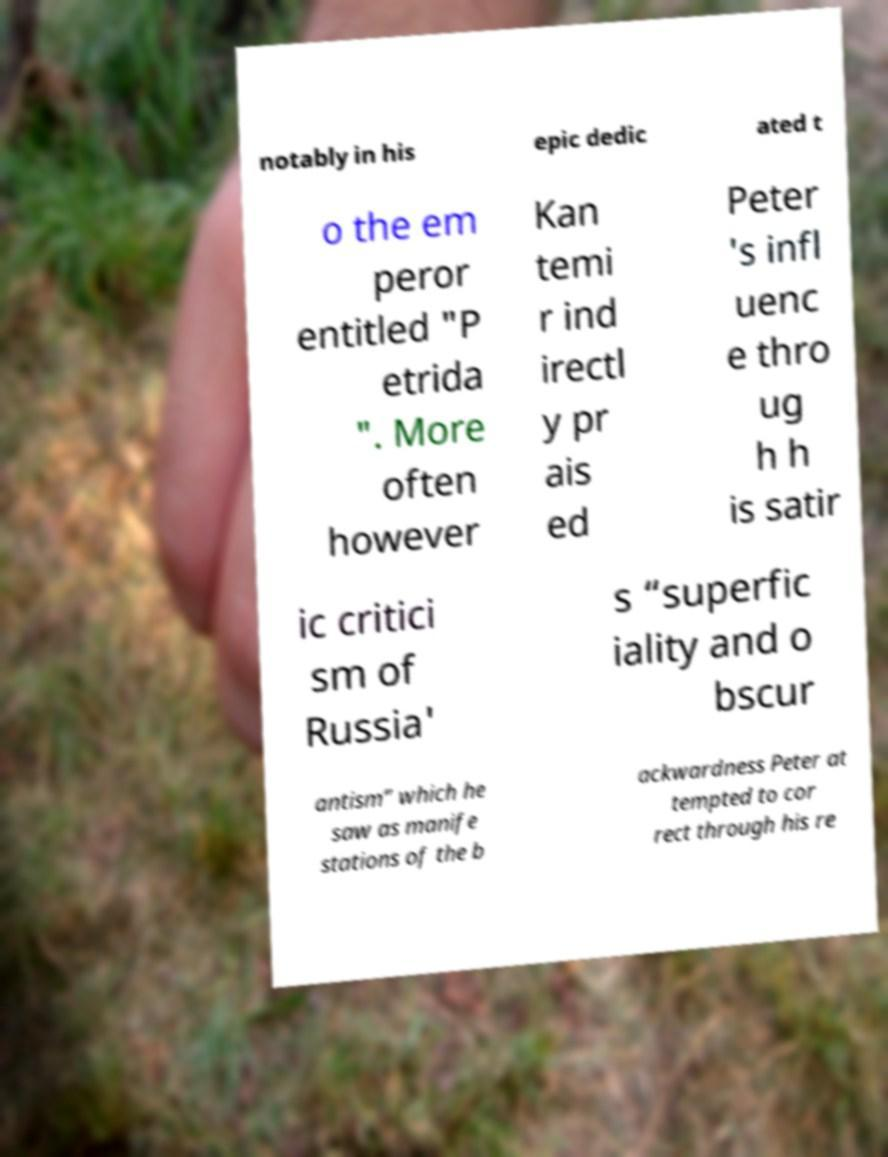Can you read and provide the text displayed in the image?This photo seems to have some interesting text. Can you extract and type it out for me? notably in his epic dedic ated t o the em peror entitled "P etrida ". More often however Kan temi r ind irectl y pr ais ed Peter 's infl uenc e thro ug h h is satir ic critici sm of Russia' s “superfic iality and o bscur antism” which he saw as manife stations of the b ackwardness Peter at tempted to cor rect through his re 